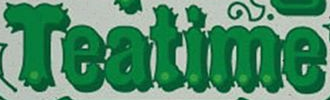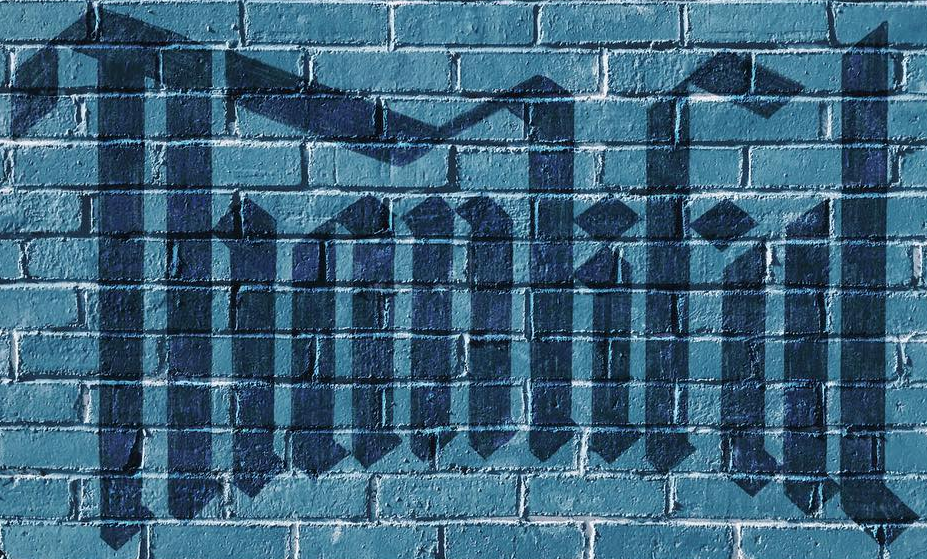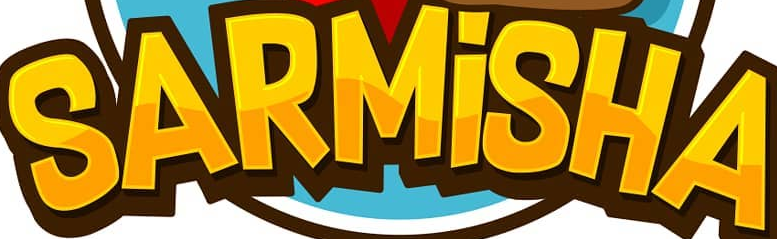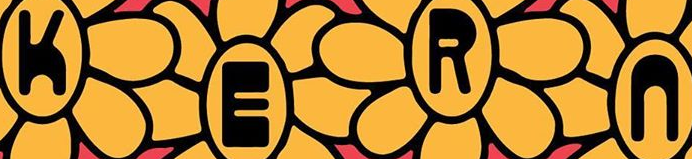Transcribe the words shown in these images in order, separated by a semicolon. Teatime; Thankful; SARMİSHA; KERn 